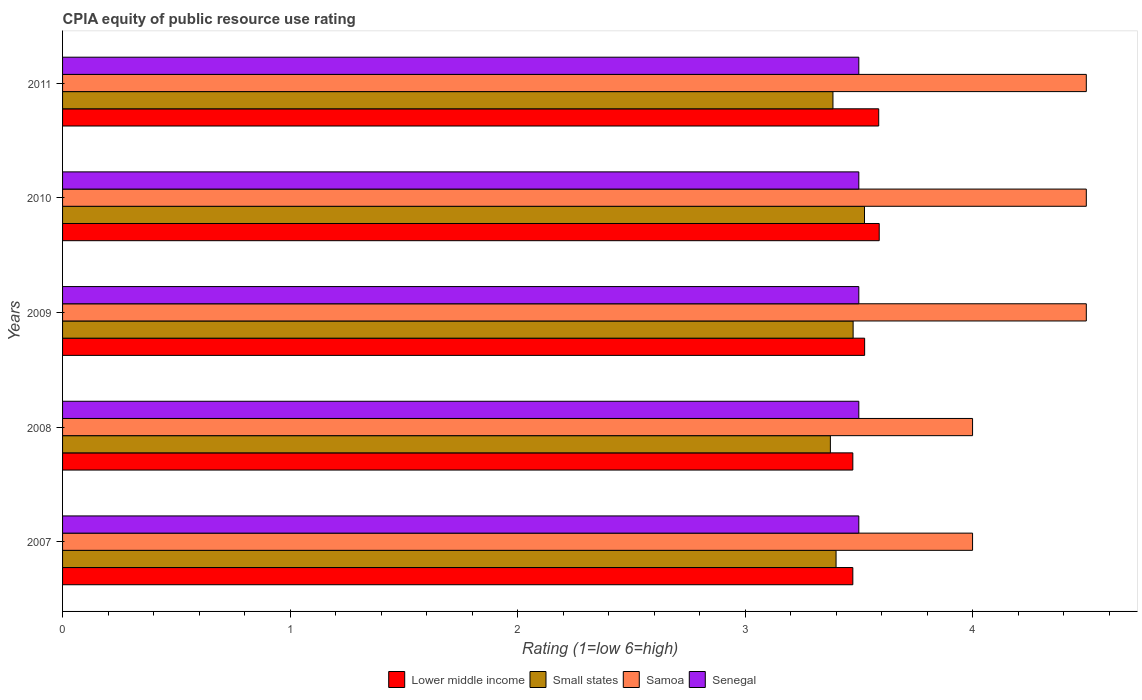How many different coloured bars are there?
Offer a terse response. 4. Are the number of bars per tick equal to the number of legend labels?
Provide a succinct answer. Yes. What is the label of the 3rd group of bars from the top?
Provide a succinct answer. 2009. In how many cases, is the number of bars for a given year not equal to the number of legend labels?
Ensure brevity in your answer.  0. Across all years, what is the maximum CPIA rating in Lower middle income?
Make the answer very short. 3.59. Across all years, what is the minimum CPIA rating in Samoa?
Ensure brevity in your answer.  4. In which year was the CPIA rating in Senegal minimum?
Your response must be concise. 2007. What is the difference between the CPIA rating in Small states in 2010 and that in 2011?
Offer a very short reply. 0.14. What is the difference between the CPIA rating in Lower middle income in 2010 and the CPIA rating in Senegal in 2007?
Offer a terse response. 0.09. In the year 2008, what is the difference between the CPIA rating in Lower middle income and CPIA rating in Senegal?
Ensure brevity in your answer.  -0.03. What is the ratio of the CPIA rating in Samoa in 2008 to that in 2011?
Your answer should be very brief. 0.89. Is the CPIA rating in Small states in 2008 less than that in 2011?
Provide a succinct answer. Yes. What is the difference between the highest and the second highest CPIA rating in Small states?
Offer a very short reply. 0.05. What is the difference between the highest and the lowest CPIA rating in Samoa?
Offer a terse response. 0.5. What does the 1st bar from the top in 2011 represents?
Offer a terse response. Senegal. What does the 1st bar from the bottom in 2007 represents?
Your response must be concise. Lower middle income. Are all the bars in the graph horizontal?
Make the answer very short. Yes. Are the values on the major ticks of X-axis written in scientific E-notation?
Give a very brief answer. No. How many legend labels are there?
Provide a succinct answer. 4. How are the legend labels stacked?
Ensure brevity in your answer.  Horizontal. What is the title of the graph?
Keep it short and to the point. CPIA equity of public resource use rating. Does "St. Kitts and Nevis" appear as one of the legend labels in the graph?
Ensure brevity in your answer.  No. What is the label or title of the X-axis?
Keep it short and to the point. Rating (1=low 6=high). What is the label or title of the Y-axis?
Offer a very short reply. Years. What is the Rating (1=low 6=high) of Lower middle income in 2007?
Provide a succinct answer. 3.47. What is the Rating (1=low 6=high) of Senegal in 2007?
Provide a succinct answer. 3.5. What is the Rating (1=low 6=high) in Lower middle income in 2008?
Provide a succinct answer. 3.47. What is the Rating (1=low 6=high) of Small states in 2008?
Your response must be concise. 3.38. What is the Rating (1=low 6=high) in Lower middle income in 2009?
Give a very brief answer. 3.53. What is the Rating (1=low 6=high) of Small states in 2009?
Give a very brief answer. 3.48. What is the Rating (1=low 6=high) in Senegal in 2009?
Keep it short and to the point. 3.5. What is the Rating (1=low 6=high) in Lower middle income in 2010?
Offer a very short reply. 3.59. What is the Rating (1=low 6=high) in Small states in 2010?
Provide a short and direct response. 3.52. What is the Rating (1=low 6=high) of Lower middle income in 2011?
Your answer should be compact. 3.59. What is the Rating (1=low 6=high) of Small states in 2011?
Provide a short and direct response. 3.39. What is the Rating (1=low 6=high) in Samoa in 2011?
Offer a terse response. 4.5. Across all years, what is the maximum Rating (1=low 6=high) of Lower middle income?
Keep it short and to the point. 3.59. Across all years, what is the maximum Rating (1=low 6=high) in Small states?
Provide a succinct answer. 3.52. Across all years, what is the maximum Rating (1=low 6=high) in Samoa?
Provide a succinct answer. 4.5. Across all years, what is the maximum Rating (1=low 6=high) in Senegal?
Provide a short and direct response. 3.5. Across all years, what is the minimum Rating (1=low 6=high) in Lower middle income?
Keep it short and to the point. 3.47. Across all years, what is the minimum Rating (1=low 6=high) in Small states?
Keep it short and to the point. 3.38. Across all years, what is the minimum Rating (1=low 6=high) in Samoa?
Offer a very short reply. 4. What is the total Rating (1=low 6=high) of Lower middle income in the graph?
Provide a short and direct response. 17.65. What is the total Rating (1=low 6=high) in Small states in the graph?
Offer a terse response. 17.16. What is the difference between the Rating (1=low 6=high) of Lower middle income in 2007 and that in 2008?
Your answer should be compact. 0. What is the difference between the Rating (1=low 6=high) of Small states in 2007 and that in 2008?
Your answer should be compact. 0.03. What is the difference between the Rating (1=low 6=high) of Lower middle income in 2007 and that in 2009?
Offer a terse response. -0.05. What is the difference between the Rating (1=low 6=high) in Small states in 2007 and that in 2009?
Keep it short and to the point. -0.07. What is the difference between the Rating (1=low 6=high) in Samoa in 2007 and that in 2009?
Give a very brief answer. -0.5. What is the difference between the Rating (1=low 6=high) in Lower middle income in 2007 and that in 2010?
Offer a terse response. -0.12. What is the difference between the Rating (1=low 6=high) of Small states in 2007 and that in 2010?
Provide a short and direct response. -0.12. What is the difference between the Rating (1=low 6=high) of Samoa in 2007 and that in 2010?
Your response must be concise. -0.5. What is the difference between the Rating (1=low 6=high) in Senegal in 2007 and that in 2010?
Your answer should be very brief. 0. What is the difference between the Rating (1=low 6=high) in Lower middle income in 2007 and that in 2011?
Provide a short and direct response. -0.11. What is the difference between the Rating (1=low 6=high) in Small states in 2007 and that in 2011?
Your answer should be compact. 0.01. What is the difference between the Rating (1=low 6=high) in Senegal in 2007 and that in 2011?
Give a very brief answer. 0. What is the difference between the Rating (1=low 6=high) in Lower middle income in 2008 and that in 2009?
Your answer should be very brief. -0.05. What is the difference between the Rating (1=low 6=high) of Small states in 2008 and that in 2009?
Make the answer very short. -0.1. What is the difference between the Rating (1=low 6=high) of Samoa in 2008 and that in 2009?
Offer a terse response. -0.5. What is the difference between the Rating (1=low 6=high) in Lower middle income in 2008 and that in 2010?
Provide a succinct answer. -0.12. What is the difference between the Rating (1=low 6=high) in Samoa in 2008 and that in 2010?
Your answer should be very brief. -0.5. What is the difference between the Rating (1=low 6=high) of Lower middle income in 2008 and that in 2011?
Your response must be concise. -0.11. What is the difference between the Rating (1=low 6=high) in Small states in 2008 and that in 2011?
Give a very brief answer. -0.01. What is the difference between the Rating (1=low 6=high) in Senegal in 2008 and that in 2011?
Provide a succinct answer. 0. What is the difference between the Rating (1=low 6=high) of Lower middle income in 2009 and that in 2010?
Provide a short and direct response. -0.06. What is the difference between the Rating (1=low 6=high) in Lower middle income in 2009 and that in 2011?
Your response must be concise. -0.06. What is the difference between the Rating (1=low 6=high) in Small states in 2009 and that in 2011?
Offer a terse response. 0.09. What is the difference between the Rating (1=low 6=high) of Samoa in 2009 and that in 2011?
Provide a short and direct response. 0. What is the difference between the Rating (1=low 6=high) of Senegal in 2009 and that in 2011?
Keep it short and to the point. 0. What is the difference between the Rating (1=low 6=high) of Lower middle income in 2010 and that in 2011?
Your response must be concise. 0. What is the difference between the Rating (1=low 6=high) of Small states in 2010 and that in 2011?
Make the answer very short. 0.14. What is the difference between the Rating (1=low 6=high) in Samoa in 2010 and that in 2011?
Your answer should be very brief. 0. What is the difference between the Rating (1=low 6=high) of Senegal in 2010 and that in 2011?
Your response must be concise. 0. What is the difference between the Rating (1=low 6=high) of Lower middle income in 2007 and the Rating (1=low 6=high) of Small states in 2008?
Give a very brief answer. 0.1. What is the difference between the Rating (1=low 6=high) in Lower middle income in 2007 and the Rating (1=low 6=high) in Samoa in 2008?
Provide a short and direct response. -0.53. What is the difference between the Rating (1=low 6=high) in Lower middle income in 2007 and the Rating (1=low 6=high) in Senegal in 2008?
Your answer should be compact. -0.03. What is the difference between the Rating (1=low 6=high) in Small states in 2007 and the Rating (1=low 6=high) in Senegal in 2008?
Offer a terse response. -0.1. What is the difference between the Rating (1=low 6=high) in Lower middle income in 2007 and the Rating (1=low 6=high) in Small states in 2009?
Offer a terse response. -0. What is the difference between the Rating (1=low 6=high) of Lower middle income in 2007 and the Rating (1=low 6=high) of Samoa in 2009?
Keep it short and to the point. -1.03. What is the difference between the Rating (1=low 6=high) of Lower middle income in 2007 and the Rating (1=low 6=high) of Senegal in 2009?
Keep it short and to the point. -0.03. What is the difference between the Rating (1=low 6=high) of Small states in 2007 and the Rating (1=low 6=high) of Senegal in 2009?
Make the answer very short. -0.1. What is the difference between the Rating (1=low 6=high) of Lower middle income in 2007 and the Rating (1=low 6=high) of Small states in 2010?
Your response must be concise. -0.05. What is the difference between the Rating (1=low 6=high) of Lower middle income in 2007 and the Rating (1=low 6=high) of Samoa in 2010?
Offer a terse response. -1.03. What is the difference between the Rating (1=low 6=high) in Lower middle income in 2007 and the Rating (1=low 6=high) in Senegal in 2010?
Your answer should be compact. -0.03. What is the difference between the Rating (1=low 6=high) in Small states in 2007 and the Rating (1=low 6=high) in Senegal in 2010?
Offer a terse response. -0.1. What is the difference between the Rating (1=low 6=high) of Samoa in 2007 and the Rating (1=low 6=high) of Senegal in 2010?
Your response must be concise. 0.5. What is the difference between the Rating (1=low 6=high) of Lower middle income in 2007 and the Rating (1=low 6=high) of Small states in 2011?
Provide a succinct answer. 0.09. What is the difference between the Rating (1=low 6=high) in Lower middle income in 2007 and the Rating (1=low 6=high) in Samoa in 2011?
Provide a short and direct response. -1.03. What is the difference between the Rating (1=low 6=high) in Lower middle income in 2007 and the Rating (1=low 6=high) in Senegal in 2011?
Your answer should be very brief. -0.03. What is the difference between the Rating (1=low 6=high) of Samoa in 2007 and the Rating (1=low 6=high) of Senegal in 2011?
Ensure brevity in your answer.  0.5. What is the difference between the Rating (1=low 6=high) of Lower middle income in 2008 and the Rating (1=low 6=high) of Small states in 2009?
Make the answer very short. -0. What is the difference between the Rating (1=low 6=high) in Lower middle income in 2008 and the Rating (1=low 6=high) in Samoa in 2009?
Your answer should be very brief. -1.03. What is the difference between the Rating (1=low 6=high) in Lower middle income in 2008 and the Rating (1=low 6=high) in Senegal in 2009?
Offer a very short reply. -0.03. What is the difference between the Rating (1=low 6=high) in Small states in 2008 and the Rating (1=low 6=high) in Samoa in 2009?
Provide a succinct answer. -1.12. What is the difference between the Rating (1=low 6=high) in Small states in 2008 and the Rating (1=low 6=high) in Senegal in 2009?
Ensure brevity in your answer.  -0.12. What is the difference between the Rating (1=low 6=high) in Lower middle income in 2008 and the Rating (1=low 6=high) in Small states in 2010?
Provide a succinct answer. -0.05. What is the difference between the Rating (1=low 6=high) of Lower middle income in 2008 and the Rating (1=low 6=high) of Samoa in 2010?
Provide a short and direct response. -1.03. What is the difference between the Rating (1=low 6=high) of Lower middle income in 2008 and the Rating (1=low 6=high) of Senegal in 2010?
Your answer should be compact. -0.03. What is the difference between the Rating (1=low 6=high) of Small states in 2008 and the Rating (1=low 6=high) of Samoa in 2010?
Give a very brief answer. -1.12. What is the difference between the Rating (1=low 6=high) in Small states in 2008 and the Rating (1=low 6=high) in Senegal in 2010?
Your answer should be very brief. -0.12. What is the difference between the Rating (1=low 6=high) of Lower middle income in 2008 and the Rating (1=low 6=high) of Small states in 2011?
Make the answer very short. 0.09. What is the difference between the Rating (1=low 6=high) in Lower middle income in 2008 and the Rating (1=low 6=high) in Samoa in 2011?
Ensure brevity in your answer.  -1.03. What is the difference between the Rating (1=low 6=high) in Lower middle income in 2008 and the Rating (1=low 6=high) in Senegal in 2011?
Ensure brevity in your answer.  -0.03. What is the difference between the Rating (1=low 6=high) of Small states in 2008 and the Rating (1=low 6=high) of Samoa in 2011?
Make the answer very short. -1.12. What is the difference between the Rating (1=low 6=high) of Small states in 2008 and the Rating (1=low 6=high) of Senegal in 2011?
Make the answer very short. -0.12. What is the difference between the Rating (1=low 6=high) in Lower middle income in 2009 and the Rating (1=low 6=high) in Small states in 2010?
Make the answer very short. 0. What is the difference between the Rating (1=low 6=high) in Lower middle income in 2009 and the Rating (1=low 6=high) in Samoa in 2010?
Keep it short and to the point. -0.97. What is the difference between the Rating (1=low 6=high) of Lower middle income in 2009 and the Rating (1=low 6=high) of Senegal in 2010?
Ensure brevity in your answer.  0.03. What is the difference between the Rating (1=low 6=high) of Small states in 2009 and the Rating (1=low 6=high) of Samoa in 2010?
Offer a very short reply. -1.02. What is the difference between the Rating (1=low 6=high) of Small states in 2009 and the Rating (1=low 6=high) of Senegal in 2010?
Your response must be concise. -0.03. What is the difference between the Rating (1=low 6=high) of Samoa in 2009 and the Rating (1=low 6=high) of Senegal in 2010?
Offer a very short reply. 1. What is the difference between the Rating (1=low 6=high) of Lower middle income in 2009 and the Rating (1=low 6=high) of Small states in 2011?
Your response must be concise. 0.14. What is the difference between the Rating (1=low 6=high) in Lower middle income in 2009 and the Rating (1=low 6=high) in Samoa in 2011?
Ensure brevity in your answer.  -0.97. What is the difference between the Rating (1=low 6=high) of Lower middle income in 2009 and the Rating (1=low 6=high) of Senegal in 2011?
Give a very brief answer. 0.03. What is the difference between the Rating (1=low 6=high) in Small states in 2009 and the Rating (1=low 6=high) in Samoa in 2011?
Ensure brevity in your answer.  -1.02. What is the difference between the Rating (1=low 6=high) in Small states in 2009 and the Rating (1=low 6=high) in Senegal in 2011?
Your answer should be compact. -0.03. What is the difference between the Rating (1=low 6=high) of Samoa in 2009 and the Rating (1=low 6=high) of Senegal in 2011?
Provide a short and direct response. 1. What is the difference between the Rating (1=low 6=high) of Lower middle income in 2010 and the Rating (1=low 6=high) of Small states in 2011?
Ensure brevity in your answer.  0.2. What is the difference between the Rating (1=low 6=high) of Lower middle income in 2010 and the Rating (1=low 6=high) of Samoa in 2011?
Provide a short and direct response. -0.91. What is the difference between the Rating (1=low 6=high) of Lower middle income in 2010 and the Rating (1=low 6=high) of Senegal in 2011?
Your answer should be very brief. 0.09. What is the difference between the Rating (1=low 6=high) in Small states in 2010 and the Rating (1=low 6=high) in Samoa in 2011?
Offer a very short reply. -0.97. What is the difference between the Rating (1=low 6=high) of Small states in 2010 and the Rating (1=low 6=high) of Senegal in 2011?
Ensure brevity in your answer.  0.03. What is the average Rating (1=low 6=high) in Lower middle income per year?
Provide a succinct answer. 3.53. What is the average Rating (1=low 6=high) of Small states per year?
Offer a very short reply. 3.43. What is the average Rating (1=low 6=high) of Senegal per year?
Offer a terse response. 3.5. In the year 2007, what is the difference between the Rating (1=low 6=high) in Lower middle income and Rating (1=low 6=high) in Small states?
Make the answer very short. 0.07. In the year 2007, what is the difference between the Rating (1=low 6=high) in Lower middle income and Rating (1=low 6=high) in Samoa?
Provide a short and direct response. -0.53. In the year 2007, what is the difference between the Rating (1=low 6=high) of Lower middle income and Rating (1=low 6=high) of Senegal?
Ensure brevity in your answer.  -0.03. In the year 2007, what is the difference between the Rating (1=low 6=high) of Small states and Rating (1=low 6=high) of Senegal?
Give a very brief answer. -0.1. In the year 2008, what is the difference between the Rating (1=low 6=high) in Lower middle income and Rating (1=low 6=high) in Small states?
Offer a very short reply. 0.1. In the year 2008, what is the difference between the Rating (1=low 6=high) in Lower middle income and Rating (1=low 6=high) in Samoa?
Make the answer very short. -0.53. In the year 2008, what is the difference between the Rating (1=low 6=high) in Lower middle income and Rating (1=low 6=high) in Senegal?
Keep it short and to the point. -0.03. In the year 2008, what is the difference between the Rating (1=low 6=high) of Small states and Rating (1=low 6=high) of Samoa?
Make the answer very short. -0.62. In the year 2008, what is the difference between the Rating (1=low 6=high) of Small states and Rating (1=low 6=high) of Senegal?
Offer a very short reply. -0.12. In the year 2009, what is the difference between the Rating (1=low 6=high) in Lower middle income and Rating (1=low 6=high) in Small states?
Ensure brevity in your answer.  0.05. In the year 2009, what is the difference between the Rating (1=low 6=high) in Lower middle income and Rating (1=low 6=high) in Samoa?
Offer a terse response. -0.97. In the year 2009, what is the difference between the Rating (1=low 6=high) of Lower middle income and Rating (1=low 6=high) of Senegal?
Your answer should be very brief. 0.03. In the year 2009, what is the difference between the Rating (1=low 6=high) of Small states and Rating (1=low 6=high) of Samoa?
Offer a terse response. -1.02. In the year 2009, what is the difference between the Rating (1=low 6=high) in Small states and Rating (1=low 6=high) in Senegal?
Keep it short and to the point. -0.03. In the year 2010, what is the difference between the Rating (1=low 6=high) in Lower middle income and Rating (1=low 6=high) in Small states?
Make the answer very short. 0.06. In the year 2010, what is the difference between the Rating (1=low 6=high) of Lower middle income and Rating (1=low 6=high) of Samoa?
Make the answer very short. -0.91. In the year 2010, what is the difference between the Rating (1=low 6=high) of Lower middle income and Rating (1=low 6=high) of Senegal?
Make the answer very short. 0.09. In the year 2010, what is the difference between the Rating (1=low 6=high) in Small states and Rating (1=low 6=high) in Samoa?
Offer a very short reply. -0.97. In the year 2010, what is the difference between the Rating (1=low 6=high) in Small states and Rating (1=low 6=high) in Senegal?
Offer a terse response. 0.03. In the year 2010, what is the difference between the Rating (1=low 6=high) of Samoa and Rating (1=low 6=high) of Senegal?
Your answer should be compact. 1. In the year 2011, what is the difference between the Rating (1=low 6=high) of Lower middle income and Rating (1=low 6=high) of Small states?
Your response must be concise. 0.2. In the year 2011, what is the difference between the Rating (1=low 6=high) in Lower middle income and Rating (1=low 6=high) in Samoa?
Your response must be concise. -0.91. In the year 2011, what is the difference between the Rating (1=low 6=high) of Lower middle income and Rating (1=low 6=high) of Senegal?
Keep it short and to the point. 0.09. In the year 2011, what is the difference between the Rating (1=low 6=high) of Small states and Rating (1=low 6=high) of Samoa?
Give a very brief answer. -1.11. In the year 2011, what is the difference between the Rating (1=low 6=high) in Small states and Rating (1=low 6=high) in Senegal?
Provide a succinct answer. -0.11. What is the ratio of the Rating (1=low 6=high) in Small states in 2007 to that in 2008?
Make the answer very short. 1.01. What is the ratio of the Rating (1=low 6=high) of Samoa in 2007 to that in 2008?
Offer a very short reply. 1. What is the ratio of the Rating (1=low 6=high) of Small states in 2007 to that in 2009?
Make the answer very short. 0.98. What is the ratio of the Rating (1=low 6=high) of Samoa in 2007 to that in 2009?
Your answer should be very brief. 0.89. What is the ratio of the Rating (1=low 6=high) of Senegal in 2007 to that in 2009?
Keep it short and to the point. 1. What is the ratio of the Rating (1=low 6=high) in Lower middle income in 2007 to that in 2010?
Your answer should be compact. 0.97. What is the ratio of the Rating (1=low 6=high) of Small states in 2007 to that in 2010?
Ensure brevity in your answer.  0.96. What is the ratio of the Rating (1=low 6=high) in Lower middle income in 2007 to that in 2011?
Keep it short and to the point. 0.97. What is the ratio of the Rating (1=low 6=high) in Small states in 2007 to that in 2011?
Offer a terse response. 1. What is the ratio of the Rating (1=low 6=high) in Senegal in 2007 to that in 2011?
Keep it short and to the point. 1. What is the ratio of the Rating (1=low 6=high) in Lower middle income in 2008 to that in 2009?
Ensure brevity in your answer.  0.99. What is the ratio of the Rating (1=low 6=high) of Small states in 2008 to that in 2009?
Your response must be concise. 0.97. What is the ratio of the Rating (1=low 6=high) in Samoa in 2008 to that in 2009?
Ensure brevity in your answer.  0.89. What is the ratio of the Rating (1=low 6=high) of Lower middle income in 2008 to that in 2010?
Your response must be concise. 0.97. What is the ratio of the Rating (1=low 6=high) in Small states in 2008 to that in 2010?
Offer a very short reply. 0.96. What is the ratio of the Rating (1=low 6=high) of Samoa in 2008 to that in 2010?
Your response must be concise. 0.89. What is the ratio of the Rating (1=low 6=high) of Senegal in 2008 to that in 2010?
Keep it short and to the point. 1. What is the ratio of the Rating (1=low 6=high) of Lower middle income in 2008 to that in 2011?
Offer a very short reply. 0.97. What is the ratio of the Rating (1=low 6=high) of Samoa in 2008 to that in 2011?
Give a very brief answer. 0.89. What is the ratio of the Rating (1=low 6=high) in Senegal in 2008 to that in 2011?
Offer a very short reply. 1. What is the ratio of the Rating (1=low 6=high) in Lower middle income in 2009 to that in 2010?
Ensure brevity in your answer.  0.98. What is the ratio of the Rating (1=low 6=high) in Small states in 2009 to that in 2010?
Ensure brevity in your answer.  0.99. What is the ratio of the Rating (1=low 6=high) of Senegal in 2009 to that in 2010?
Keep it short and to the point. 1. What is the ratio of the Rating (1=low 6=high) of Lower middle income in 2009 to that in 2011?
Offer a terse response. 0.98. What is the ratio of the Rating (1=low 6=high) of Small states in 2009 to that in 2011?
Offer a very short reply. 1.03. What is the ratio of the Rating (1=low 6=high) of Samoa in 2009 to that in 2011?
Offer a terse response. 1. What is the ratio of the Rating (1=low 6=high) of Lower middle income in 2010 to that in 2011?
Keep it short and to the point. 1. What is the ratio of the Rating (1=low 6=high) of Small states in 2010 to that in 2011?
Ensure brevity in your answer.  1.04. What is the ratio of the Rating (1=low 6=high) in Senegal in 2010 to that in 2011?
Your answer should be very brief. 1. What is the difference between the highest and the second highest Rating (1=low 6=high) of Lower middle income?
Offer a very short reply. 0. What is the difference between the highest and the second highest Rating (1=low 6=high) of Small states?
Your answer should be very brief. 0.05. What is the difference between the highest and the second highest Rating (1=low 6=high) in Samoa?
Your answer should be very brief. 0. What is the difference between the highest and the lowest Rating (1=low 6=high) of Lower middle income?
Give a very brief answer. 0.12. What is the difference between the highest and the lowest Rating (1=low 6=high) in Small states?
Your response must be concise. 0.15. What is the difference between the highest and the lowest Rating (1=low 6=high) of Samoa?
Provide a succinct answer. 0.5. What is the difference between the highest and the lowest Rating (1=low 6=high) in Senegal?
Your answer should be compact. 0. 